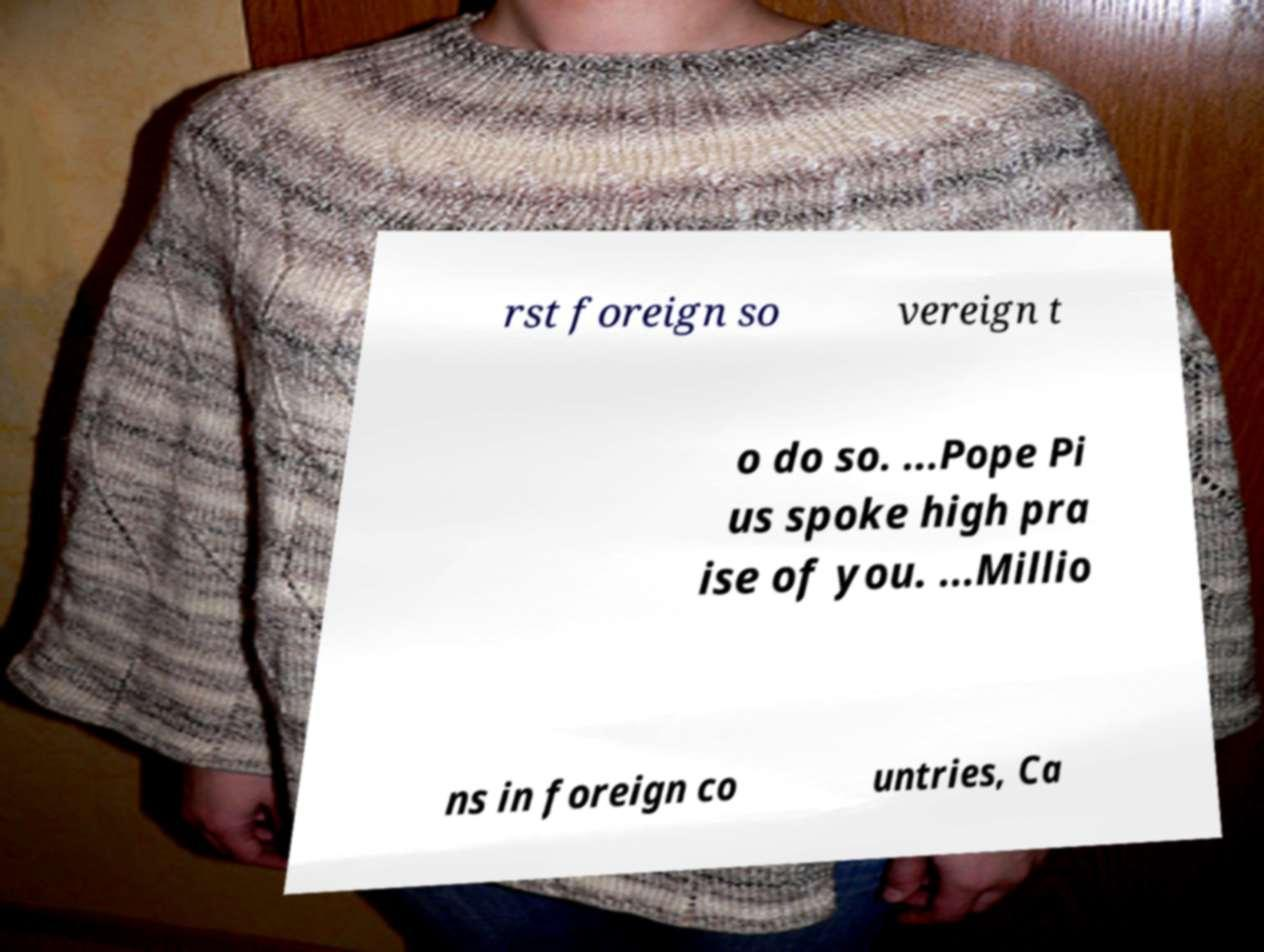For documentation purposes, I need the text within this image transcribed. Could you provide that? rst foreign so vereign t o do so. ...Pope Pi us spoke high pra ise of you. ...Millio ns in foreign co untries, Ca 